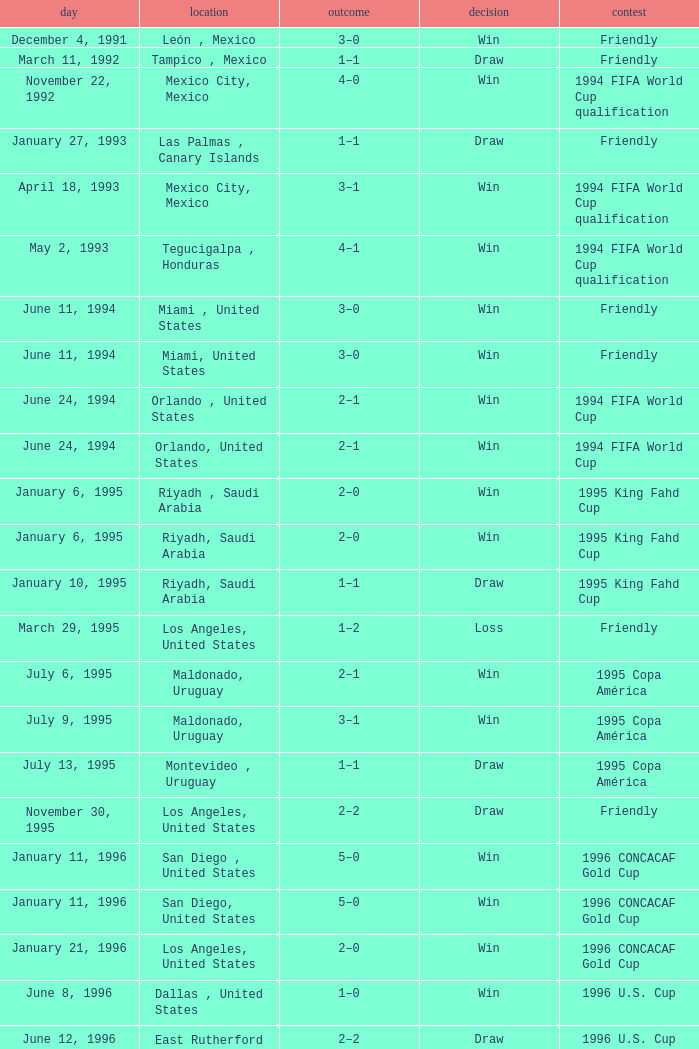Help me parse the entirety of this table. {'header': ['day', 'location', 'outcome', 'decision', 'contest'], 'rows': [['December 4, 1991', 'León , Mexico', '3–0', 'Win', 'Friendly'], ['March 11, 1992', 'Tampico , Mexico', '1–1', 'Draw', 'Friendly'], ['November 22, 1992', 'Mexico City, Mexico', '4–0', 'Win', '1994 FIFA World Cup qualification'], ['January 27, 1993', 'Las Palmas , Canary Islands', '1–1', 'Draw', 'Friendly'], ['April 18, 1993', 'Mexico City, Mexico', '3–1', 'Win', '1994 FIFA World Cup qualification'], ['May 2, 1993', 'Tegucigalpa , Honduras', '4–1', 'Win', '1994 FIFA World Cup qualification'], ['June 11, 1994', 'Miami , United States', '3–0', 'Win', 'Friendly'], ['June 11, 1994', 'Miami, United States', '3–0', 'Win', 'Friendly'], ['June 24, 1994', 'Orlando , United States', '2–1', 'Win', '1994 FIFA World Cup'], ['June 24, 1994', 'Orlando, United States', '2–1', 'Win', '1994 FIFA World Cup'], ['January 6, 1995', 'Riyadh , Saudi Arabia', '2–0', 'Win', '1995 King Fahd Cup'], ['January 6, 1995', 'Riyadh, Saudi Arabia', '2–0', 'Win', '1995 King Fahd Cup'], ['January 10, 1995', 'Riyadh, Saudi Arabia', '1–1', 'Draw', '1995 King Fahd Cup'], ['March 29, 1995', 'Los Angeles, United States', '1–2', 'Loss', 'Friendly'], ['July 6, 1995', 'Maldonado, Uruguay', '2–1', 'Win', '1995 Copa América'], ['July 9, 1995', 'Maldonado, Uruguay', '3–1', 'Win', '1995 Copa América'], ['July 13, 1995', 'Montevideo , Uruguay', '1–1', 'Draw', '1995 Copa América'], ['November 30, 1995', 'Los Angeles, United States', '2–2', 'Draw', 'Friendly'], ['January 11, 1996', 'San Diego , United States', '5–0', 'Win', '1996 CONCACAF Gold Cup'], ['January 11, 1996', 'San Diego, United States', '5–0', 'Win', '1996 CONCACAF Gold Cup'], ['January 21, 1996', 'Los Angeles, United States', '2–0', 'Win', '1996 CONCACAF Gold Cup'], ['June 8, 1996', 'Dallas , United States', '1–0', 'Win', '1996 U.S. Cup'], ['June 12, 1996', 'East Rutherford , United States', '2–2', 'Draw', '1996 U.S. Cup'], ['June 12, 1996', 'East Rutherford, United States', '2–2', 'Draw', '1996 U.S. Cup'], ['June 8, 1997', 'San Salvador , El Salvador', '1–0', 'Win', '1998 FIFA World Cup qualification'], ['October 5, 1997', 'Mexico City, Mexico', '5–0', 'Win', '1998 FIFA World Cup qualification'], ['May 31, 1998', 'Lausanne , Switzerland', '2–1', 'Win', 'Friendly']]} What is Competition, when Date is "January 11, 1996", when Venue is "San Diego , United States"? 1996 CONCACAF Gold Cup, 1996 CONCACAF Gold Cup. 